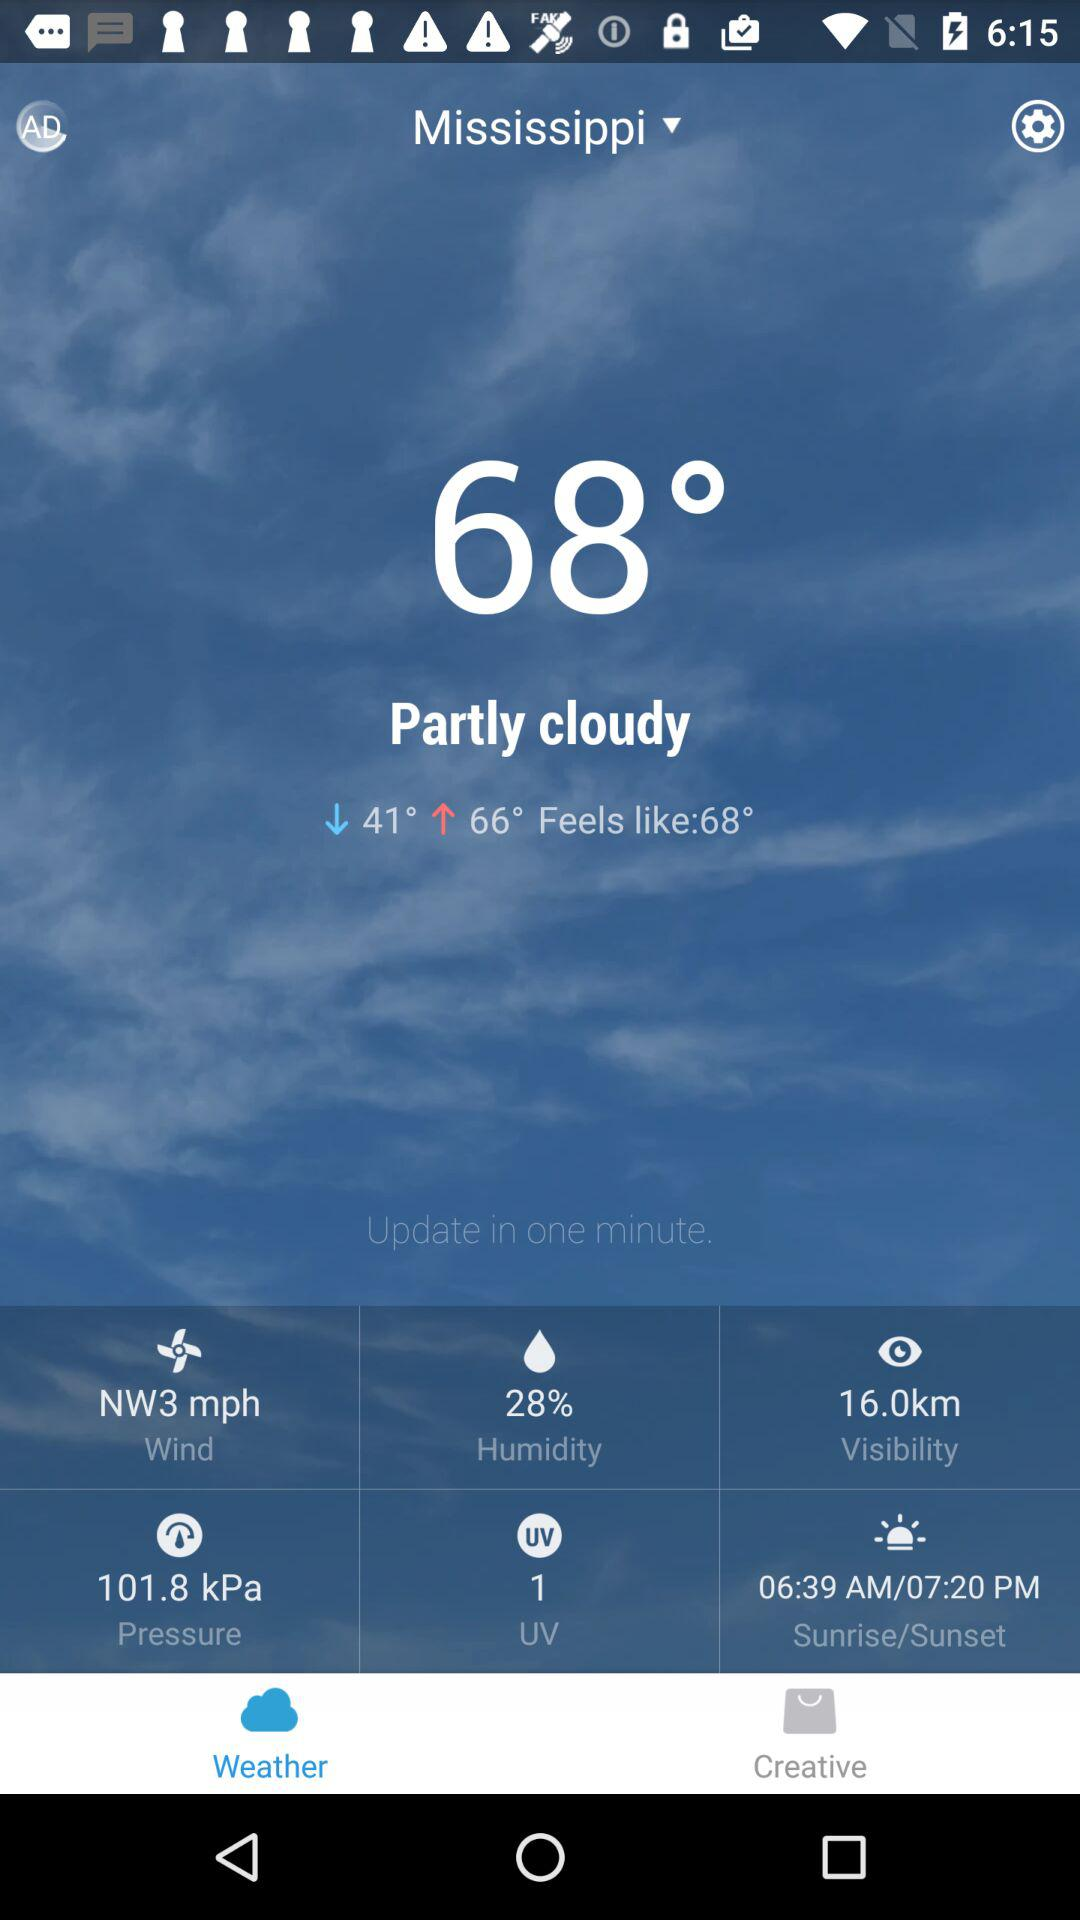What is the humidity of the current weather conditions?
Answer the question using a single word or phrase. 28% 